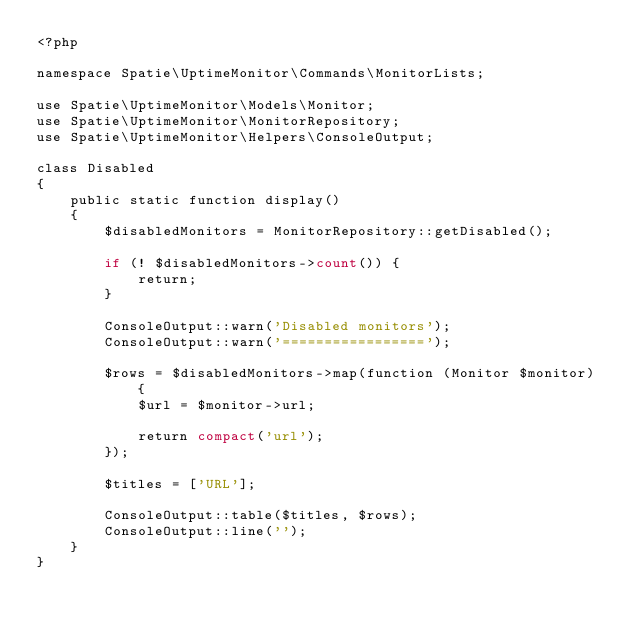Convert code to text. <code><loc_0><loc_0><loc_500><loc_500><_PHP_><?php

namespace Spatie\UptimeMonitor\Commands\MonitorLists;

use Spatie\UptimeMonitor\Models\Monitor;
use Spatie\UptimeMonitor\MonitorRepository;
use Spatie\UptimeMonitor\Helpers\ConsoleOutput;

class Disabled
{
    public static function display()
    {
        $disabledMonitors = MonitorRepository::getDisabled();

        if (! $disabledMonitors->count()) {
            return;
        }

        ConsoleOutput::warn('Disabled monitors');
        ConsoleOutput::warn('=================');

        $rows = $disabledMonitors->map(function (Monitor $monitor) {
            $url = $monitor->url;

            return compact('url');
        });

        $titles = ['URL'];

        ConsoleOutput::table($titles, $rows);
        ConsoleOutput::line('');
    }
}
</code> 